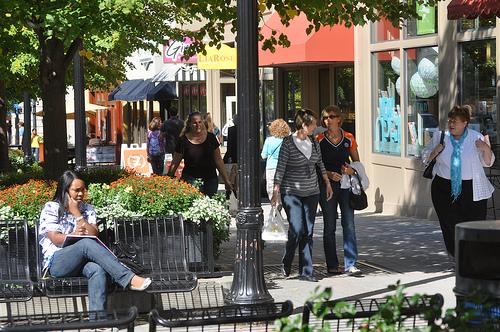Question: where is the trash bin?
Choices:
A. In the upper right corner.
B. In the lower left corner.
C. In the lower right corner.
D. In the upper left corner.
Answer with the letter. Answer: C Question: what are the black marks on the sidewalk on the right?
Choices:
A. Mud.
B. Bike tracks.
C. A shadow.
D. Dog tracks.
Answer with the letter. Answer: C Question: who is wearing black pants?
Choices:
A. The woman on the right.
B. The woman on the left.
C. The man on the right.
D. The man on the left.
Answer with the letter. Answer: A 